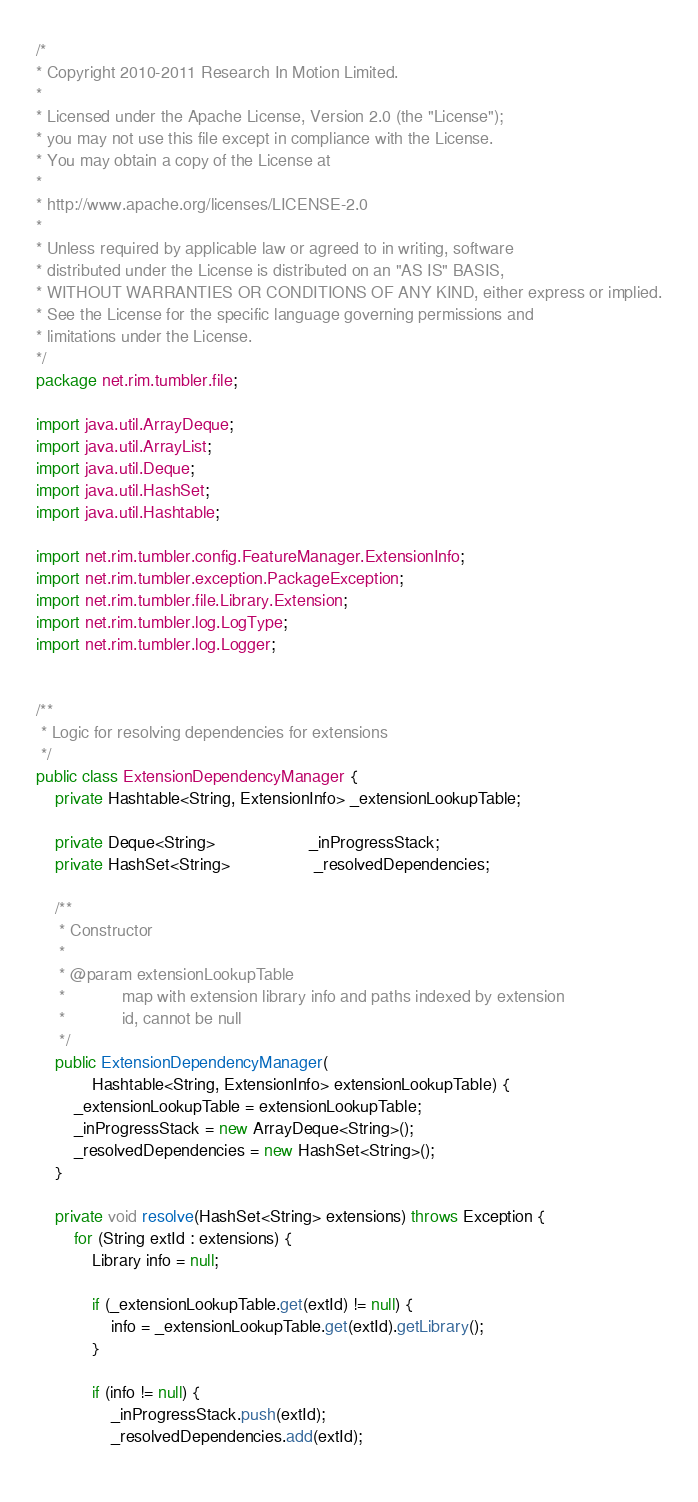Convert code to text. <code><loc_0><loc_0><loc_500><loc_500><_Java_>/*
* Copyright 2010-2011 Research In Motion Limited.
*
* Licensed under the Apache License, Version 2.0 (the "License");
* you may not use this file except in compliance with the License.
* You may obtain a copy of the License at
*
* http://www.apache.org/licenses/LICENSE-2.0
*
* Unless required by applicable law or agreed to in writing, software
* distributed under the License is distributed on an "AS IS" BASIS,
* WITHOUT WARRANTIES OR CONDITIONS OF ANY KIND, either express or implied.
* See the License for the specific language governing permissions and
* limitations under the License.
*/
package net.rim.tumbler.file;

import java.util.ArrayDeque;
import java.util.ArrayList;
import java.util.Deque;
import java.util.HashSet;
import java.util.Hashtable;

import net.rim.tumbler.config.FeatureManager.ExtensionInfo;
import net.rim.tumbler.exception.PackageException;
import net.rim.tumbler.file.Library.Extension;
import net.rim.tumbler.log.LogType;
import net.rim.tumbler.log.Logger;


/**
 * Logic for resolving dependencies for extensions
 */
public class ExtensionDependencyManager {
	private Hashtable<String, ExtensionInfo> _extensionLookupTable;	
	
	private Deque<String>                    _inProgressStack;
	private HashSet<String>                  _resolvedDependencies;	
	
	/**
	 * Constructor
	 * 
	 * @param extensionLookupTable
	 *            map with extension library info and paths indexed by extension
	 *            id, cannot be null
	 */
	public ExtensionDependencyManager(
			Hashtable<String, ExtensionInfo> extensionLookupTable) {
		_extensionLookupTable = extensionLookupTable;
		_inProgressStack = new ArrayDeque<String>();
		_resolvedDependencies = new HashSet<String>();
	}

	private void resolve(HashSet<String> extensions) throws Exception {
		for (String extId : extensions) {
			Library info = null;
			
			if (_extensionLookupTable.get(extId) != null) {
				info = _extensionLookupTable.get(extId).getLibrary();
			}
			
			if (info != null) {
				_inProgressStack.push(extId);
				_resolvedDependencies.add(extId);								
				</code> 